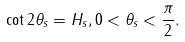<formula> <loc_0><loc_0><loc_500><loc_500>\cot 2 \theta _ { s } = H _ { s } , 0 < \theta _ { s } < \frac { \pi } { 2 } .</formula> 